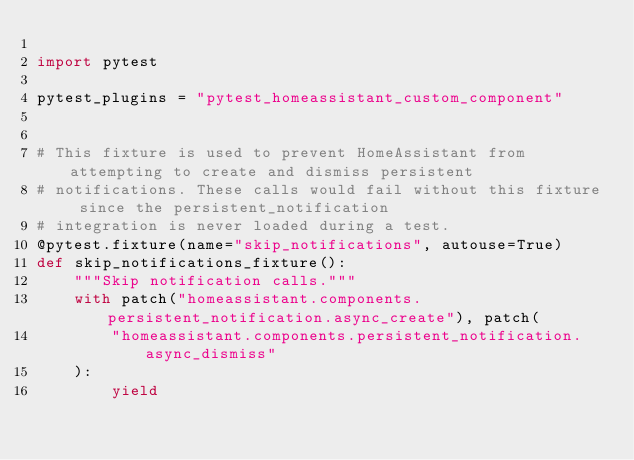Convert code to text. <code><loc_0><loc_0><loc_500><loc_500><_Python_>
import pytest

pytest_plugins = "pytest_homeassistant_custom_component"


# This fixture is used to prevent HomeAssistant from attempting to create and dismiss persistent
# notifications. These calls would fail without this fixture since the persistent_notification
# integration is never loaded during a test.
@pytest.fixture(name="skip_notifications", autouse=True)
def skip_notifications_fixture():
    """Skip notification calls."""
    with patch("homeassistant.components.persistent_notification.async_create"), patch(
        "homeassistant.components.persistent_notification.async_dismiss"
    ):
        yield
</code> 